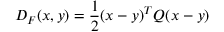Convert formula to latex. <formula><loc_0><loc_0><loc_500><loc_500>D _ { F } ( x , y ) = { \frac { 1 } { 2 } } ( x - y ) ^ { T } Q ( x - y )</formula> 